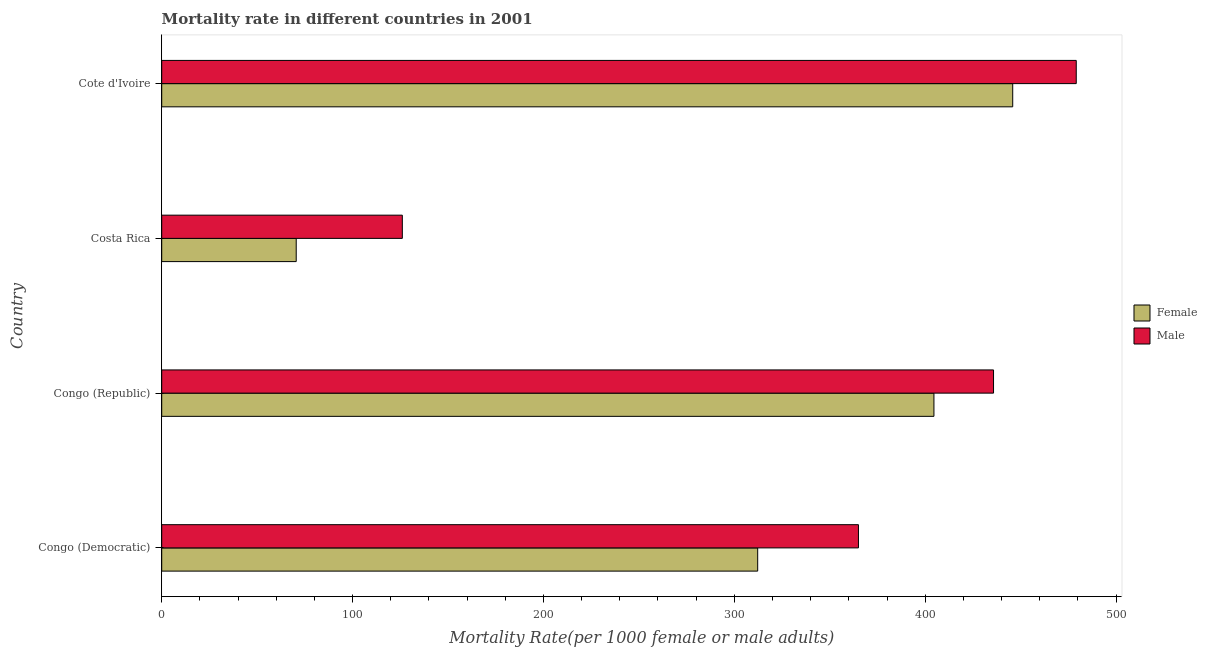How many groups of bars are there?
Offer a terse response. 4. What is the label of the 3rd group of bars from the top?
Keep it short and to the point. Congo (Republic). In how many cases, is the number of bars for a given country not equal to the number of legend labels?
Keep it short and to the point. 0. What is the male mortality rate in Costa Rica?
Give a very brief answer. 126.06. Across all countries, what is the maximum female mortality rate?
Make the answer very short. 445.87. Across all countries, what is the minimum male mortality rate?
Give a very brief answer. 126.06. In which country was the male mortality rate maximum?
Your answer should be compact. Cote d'Ivoire. In which country was the male mortality rate minimum?
Offer a terse response. Costa Rica. What is the total male mortality rate in the graph?
Your answer should be compact. 1406.07. What is the difference between the female mortality rate in Congo (Democratic) and that in Costa Rica?
Offer a very short reply. 241.78. What is the difference between the female mortality rate in Congo (Democratic) and the male mortality rate in Congo (Republic)?
Give a very brief answer. -123.57. What is the average female mortality rate per country?
Offer a very short reply. 308.29. What is the difference between the male mortality rate and female mortality rate in Congo (Republic)?
Provide a succinct answer. 31.22. In how many countries, is the female mortality rate greater than 460 ?
Give a very brief answer. 0. What is the ratio of the female mortality rate in Congo (Democratic) to that in Congo (Republic)?
Keep it short and to the point. 0.77. Is the female mortality rate in Congo (Republic) less than that in Costa Rica?
Make the answer very short. No. Is the difference between the female mortality rate in Congo (Republic) and Costa Rica greater than the difference between the male mortality rate in Congo (Republic) and Costa Rica?
Offer a terse response. Yes. What is the difference between the highest and the second highest male mortality rate?
Ensure brevity in your answer.  43.34. What is the difference between the highest and the lowest female mortality rate?
Your answer should be very brief. 375.4. In how many countries, is the female mortality rate greater than the average female mortality rate taken over all countries?
Your answer should be compact. 3. What does the 1st bar from the top in Costa Rica represents?
Offer a very short reply. Male. What does the 2nd bar from the bottom in Congo (Democratic) represents?
Your response must be concise. Male. How many bars are there?
Give a very brief answer. 8. What is the difference between two consecutive major ticks on the X-axis?
Offer a very short reply. 100. Does the graph contain any zero values?
Keep it short and to the point. No. Does the graph contain grids?
Keep it short and to the point. No. How many legend labels are there?
Offer a very short reply. 2. How are the legend labels stacked?
Give a very brief answer. Vertical. What is the title of the graph?
Offer a very short reply. Mortality rate in different countries in 2001. Does "Male entrants" appear as one of the legend labels in the graph?
Give a very brief answer. No. What is the label or title of the X-axis?
Provide a short and direct response. Mortality Rate(per 1000 female or male adults). What is the label or title of the Y-axis?
Ensure brevity in your answer.  Country. What is the Mortality Rate(per 1000 female or male adults) in Female in Congo (Democratic)?
Keep it short and to the point. 312.25. What is the Mortality Rate(per 1000 female or male adults) in Male in Congo (Democratic)?
Your answer should be very brief. 365.04. What is the Mortality Rate(per 1000 female or male adults) in Female in Congo (Republic)?
Your answer should be compact. 404.59. What is the Mortality Rate(per 1000 female or male adults) of Male in Congo (Republic)?
Ensure brevity in your answer.  435.81. What is the Mortality Rate(per 1000 female or male adults) in Female in Costa Rica?
Give a very brief answer. 70.47. What is the Mortality Rate(per 1000 female or male adults) in Male in Costa Rica?
Provide a succinct answer. 126.06. What is the Mortality Rate(per 1000 female or male adults) in Female in Cote d'Ivoire?
Your response must be concise. 445.87. What is the Mortality Rate(per 1000 female or male adults) in Male in Cote d'Ivoire?
Your answer should be compact. 479.15. Across all countries, what is the maximum Mortality Rate(per 1000 female or male adults) of Female?
Provide a succinct answer. 445.87. Across all countries, what is the maximum Mortality Rate(per 1000 female or male adults) in Male?
Ensure brevity in your answer.  479.15. Across all countries, what is the minimum Mortality Rate(per 1000 female or male adults) of Female?
Provide a short and direct response. 70.47. Across all countries, what is the minimum Mortality Rate(per 1000 female or male adults) in Male?
Offer a very short reply. 126.06. What is the total Mortality Rate(per 1000 female or male adults) of Female in the graph?
Offer a terse response. 1233.18. What is the total Mortality Rate(per 1000 female or male adults) of Male in the graph?
Your answer should be compact. 1406.07. What is the difference between the Mortality Rate(per 1000 female or male adults) of Female in Congo (Democratic) and that in Congo (Republic)?
Offer a terse response. -92.35. What is the difference between the Mortality Rate(per 1000 female or male adults) in Male in Congo (Democratic) and that in Congo (Republic)?
Your answer should be compact. -70.78. What is the difference between the Mortality Rate(per 1000 female or male adults) of Female in Congo (Democratic) and that in Costa Rica?
Make the answer very short. 241.78. What is the difference between the Mortality Rate(per 1000 female or male adults) of Male in Congo (Democratic) and that in Costa Rica?
Ensure brevity in your answer.  238.98. What is the difference between the Mortality Rate(per 1000 female or male adults) of Female in Congo (Democratic) and that in Cote d'Ivoire?
Offer a terse response. -133.63. What is the difference between the Mortality Rate(per 1000 female or male adults) of Male in Congo (Democratic) and that in Cote d'Ivoire?
Your answer should be very brief. -114.11. What is the difference between the Mortality Rate(per 1000 female or male adults) of Female in Congo (Republic) and that in Costa Rica?
Your answer should be compact. 334.12. What is the difference between the Mortality Rate(per 1000 female or male adults) in Male in Congo (Republic) and that in Costa Rica?
Keep it short and to the point. 309.75. What is the difference between the Mortality Rate(per 1000 female or male adults) of Female in Congo (Republic) and that in Cote d'Ivoire?
Offer a terse response. -41.28. What is the difference between the Mortality Rate(per 1000 female or male adults) of Male in Congo (Republic) and that in Cote d'Ivoire?
Provide a short and direct response. -43.34. What is the difference between the Mortality Rate(per 1000 female or male adults) in Female in Costa Rica and that in Cote d'Ivoire?
Offer a very short reply. -375.4. What is the difference between the Mortality Rate(per 1000 female or male adults) in Male in Costa Rica and that in Cote d'Ivoire?
Your response must be concise. -353.09. What is the difference between the Mortality Rate(per 1000 female or male adults) in Female in Congo (Democratic) and the Mortality Rate(per 1000 female or male adults) in Male in Congo (Republic)?
Offer a terse response. -123.57. What is the difference between the Mortality Rate(per 1000 female or male adults) of Female in Congo (Democratic) and the Mortality Rate(per 1000 female or male adults) of Male in Costa Rica?
Your response must be concise. 186.18. What is the difference between the Mortality Rate(per 1000 female or male adults) of Female in Congo (Democratic) and the Mortality Rate(per 1000 female or male adults) of Male in Cote d'Ivoire?
Give a very brief answer. -166.91. What is the difference between the Mortality Rate(per 1000 female or male adults) of Female in Congo (Republic) and the Mortality Rate(per 1000 female or male adults) of Male in Costa Rica?
Offer a very short reply. 278.53. What is the difference between the Mortality Rate(per 1000 female or male adults) of Female in Congo (Republic) and the Mortality Rate(per 1000 female or male adults) of Male in Cote d'Ivoire?
Make the answer very short. -74.56. What is the difference between the Mortality Rate(per 1000 female or male adults) in Female in Costa Rica and the Mortality Rate(per 1000 female or male adults) in Male in Cote d'Ivoire?
Offer a terse response. -408.68. What is the average Mortality Rate(per 1000 female or male adults) of Female per country?
Give a very brief answer. 308.29. What is the average Mortality Rate(per 1000 female or male adults) of Male per country?
Your answer should be compact. 351.52. What is the difference between the Mortality Rate(per 1000 female or male adults) in Female and Mortality Rate(per 1000 female or male adults) in Male in Congo (Democratic)?
Your response must be concise. -52.8. What is the difference between the Mortality Rate(per 1000 female or male adults) in Female and Mortality Rate(per 1000 female or male adults) in Male in Congo (Republic)?
Keep it short and to the point. -31.22. What is the difference between the Mortality Rate(per 1000 female or male adults) in Female and Mortality Rate(per 1000 female or male adults) in Male in Costa Rica?
Give a very brief answer. -55.59. What is the difference between the Mortality Rate(per 1000 female or male adults) of Female and Mortality Rate(per 1000 female or male adults) of Male in Cote d'Ivoire?
Your response must be concise. -33.28. What is the ratio of the Mortality Rate(per 1000 female or male adults) in Female in Congo (Democratic) to that in Congo (Republic)?
Offer a very short reply. 0.77. What is the ratio of the Mortality Rate(per 1000 female or male adults) in Male in Congo (Democratic) to that in Congo (Republic)?
Provide a short and direct response. 0.84. What is the ratio of the Mortality Rate(per 1000 female or male adults) in Female in Congo (Democratic) to that in Costa Rica?
Offer a terse response. 4.43. What is the ratio of the Mortality Rate(per 1000 female or male adults) of Male in Congo (Democratic) to that in Costa Rica?
Keep it short and to the point. 2.9. What is the ratio of the Mortality Rate(per 1000 female or male adults) in Female in Congo (Democratic) to that in Cote d'Ivoire?
Ensure brevity in your answer.  0.7. What is the ratio of the Mortality Rate(per 1000 female or male adults) in Male in Congo (Democratic) to that in Cote d'Ivoire?
Provide a short and direct response. 0.76. What is the ratio of the Mortality Rate(per 1000 female or male adults) of Female in Congo (Republic) to that in Costa Rica?
Keep it short and to the point. 5.74. What is the ratio of the Mortality Rate(per 1000 female or male adults) in Male in Congo (Republic) to that in Costa Rica?
Offer a terse response. 3.46. What is the ratio of the Mortality Rate(per 1000 female or male adults) of Female in Congo (Republic) to that in Cote d'Ivoire?
Offer a terse response. 0.91. What is the ratio of the Mortality Rate(per 1000 female or male adults) of Male in Congo (Republic) to that in Cote d'Ivoire?
Your answer should be very brief. 0.91. What is the ratio of the Mortality Rate(per 1000 female or male adults) in Female in Costa Rica to that in Cote d'Ivoire?
Offer a very short reply. 0.16. What is the ratio of the Mortality Rate(per 1000 female or male adults) in Male in Costa Rica to that in Cote d'Ivoire?
Give a very brief answer. 0.26. What is the difference between the highest and the second highest Mortality Rate(per 1000 female or male adults) in Female?
Make the answer very short. 41.28. What is the difference between the highest and the second highest Mortality Rate(per 1000 female or male adults) of Male?
Keep it short and to the point. 43.34. What is the difference between the highest and the lowest Mortality Rate(per 1000 female or male adults) in Female?
Keep it short and to the point. 375.4. What is the difference between the highest and the lowest Mortality Rate(per 1000 female or male adults) in Male?
Provide a short and direct response. 353.09. 